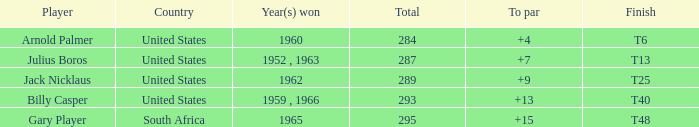What was Gary Player's highest total when his To par was over 15? None. Could you help me parse every detail presented in this table? {'header': ['Player', 'Country', 'Year(s) won', 'Total', 'To par', 'Finish'], 'rows': [['Arnold Palmer', 'United States', '1960', '284', '+4', 'T6'], ['Julius Boros', 'United States', '1952 , 1963', '287', '+7', 'T13'], ['Jack Nicklaus', 'United States', '1962', '289', '+9', 'T25'], ['Billy Casper', 'United States', '1959 , 1966', '293', '+13', 'T40'], ['Gary Player', 'South Africa', '1965', '295', '+15', 'T48']]} 